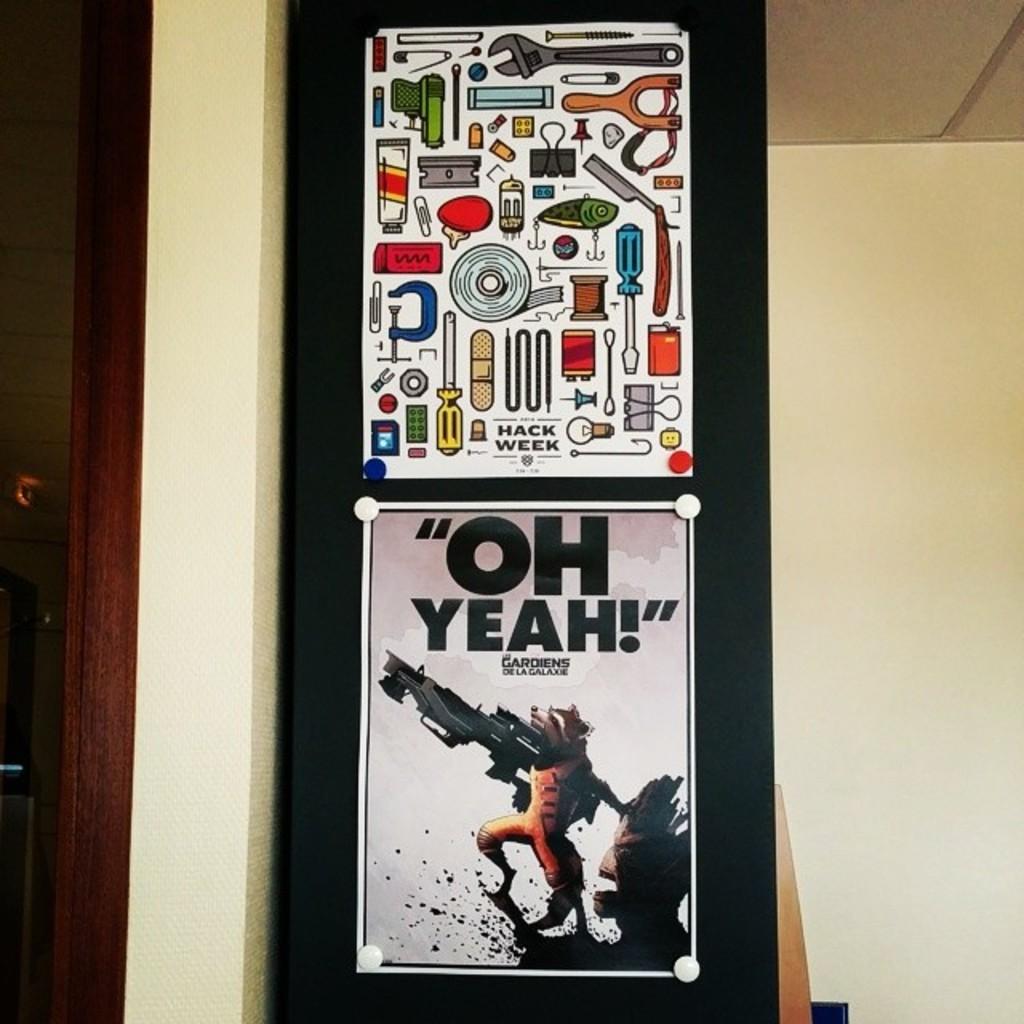What does it say on the bottom photo?
Keep it short and to the point. Oh yeah. 